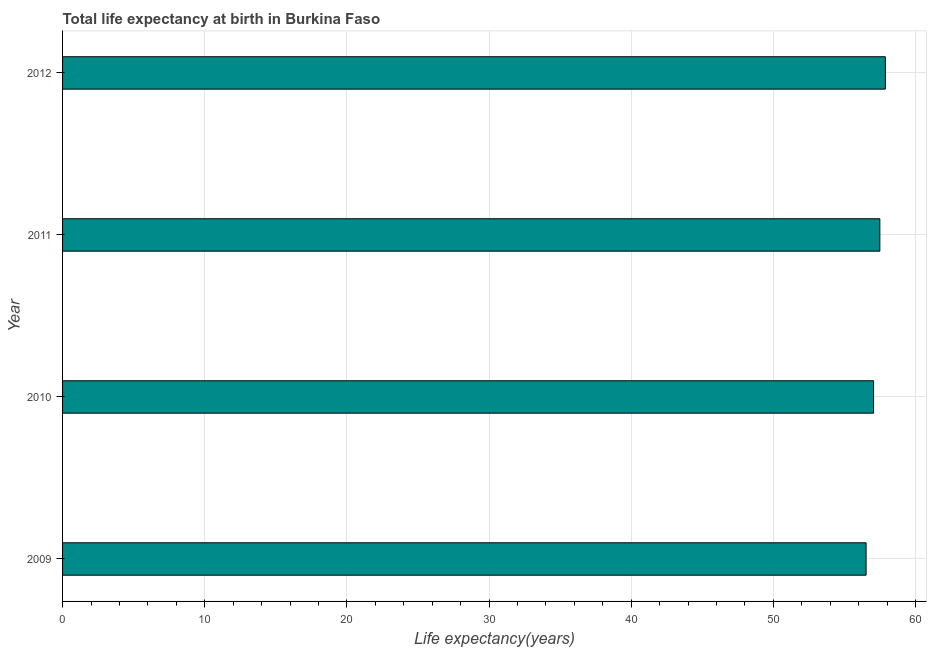Does the graph contain grids?
Offer a very short reply. Yes. What is the title of the graph?
Keep it short and to the point. Total life expectancy at birth in Burkina Faso. What is the label or title of the X-axis?
Keep it short and to the point. Life expectancy(years). What is the life expectancy at birth in 2012?
Your answer should be compact. 57.88. Across all years, what is the maximum life expectancy at birth?
Offer a very short reply. 57.88. Across all years, what is the minimum life expectancy at birth?
Your response must be concise. 56.52. In which year was the life expectancy at birth minimum?
Provide a succinct answer. 2009. What is the sum of the life expectancy at birth?
Offer a very short reply. 228.95. What is the difference between the life expectancy at birth in 2010 and 2012?
Give a very brief answer. -0.83. What is the average life expectancy at birth per year?
Provide a short and direct response. 57.24. What is the median life expectancy at birth?
Offer a very short reply. 57.27. In how many years, is the life expectancy at birth greater than 4 years?
Keep it short and to the point. 4. Do a majority of the years between 2009 and 2012 (inclusive) have life expectancy at birth greater than 46 years?
Provide a short and direct response. Yes. Is the life expectancy at birth in 2009 less than that in 2012?
Offer a very short reply. Yes. Is the difference between the life expectancy at birth in 2010 and 2011 greater than the difference between any two years?
Provide a succinct answer. No. What is the difference between the highest and the second highest life expectancy at birth?
Provide a short and direct response. 0.39. What is the difference between the highest and the lowest life expectancy at birth?
Provide a short and direct response. 1.35. In how many years, is the life expectancy at birth greater than the average life expectancy at birth taken over all years?
Your response must be concise. 2. Are all the bars in the graph horizontal?
Your answer should be very brief. Yes. How many years are there in the graph?
Make the answer very short. 4. What is the difference between two consecutive major ticks on the X-axis?
Your answer should be very brief. 10. What is the Life expectancy(years) in 2009?
Your answer should be compact. 56.52. What is the Life expectancy(years) of 2010?
Provide a succinct answer. 57.05. What is the Life expectancy(years) of 2011?
Your answer should be compact. 57.49. What is the Life expectancy(years) in 2012?
Provide a succinct answer. 57.88. What is the difference between the Life expectancy(years) in 2009 and 2010?
Ensure brevity in your answer.  -0.53. What is the difference between the Life expectancy(years) in 2009 and 2011?
Provide a succinct answer. -0.97. What is the difference between the Life expectancy(years) in 2009 and 2012?
Ensure brevity in your answer.  -1.35. What is the difference between the Life expectancy(years) in 2010 and 2011?
Your answer should be very brief. -0.44. What is the difference between the Life expectancy(years) in 2010 and 2012?
Make the answer very short. -0.83. What is the difference between the Life expectancy(years) in 2011 and 2012?
Your response must be concise. -0.39. What is the ratio of the Life expectancy(years) in 2009 to that in 2012?
Provide a short and direct response. 0.98. What is the ratio of the Life expectancy(years) in 2010 to that in 2011?
Offer a terse response. 0.99. 